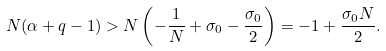Convert formula to latex. <formula><loc_0><loc_0><loc_500><loc_500>N ( \alpha + q - 1 ) > N \left ( - \frac { 1 } { N } + \sigma _ { 0 } - \frac { \sigma _ { 0 } } { 2 } \right ) = - 1 + \frac { \sigma _ { 0 } N } { 2 } .</formula> 